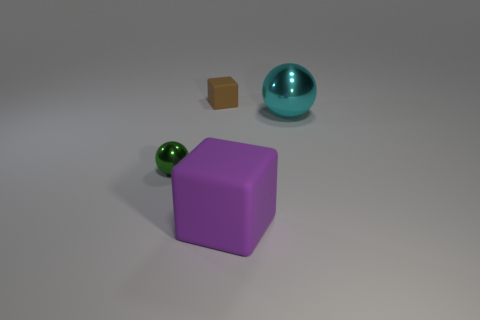Add 1 green cylinders. How many objects exist? 5 Subtract all small green cylinders. Subtract all large cyan objects. How many objects are left? 3 Add 4 purple blocks. How many purple blocks are left? 5 Add 1 cyan metal balls. How many cyan metal balls exist? 2 Subtract 0 brown cylinders. How many objects are left? 4 Subtract all blue spheres. Subtract all brown cylinders. How many spheres are left? 2 